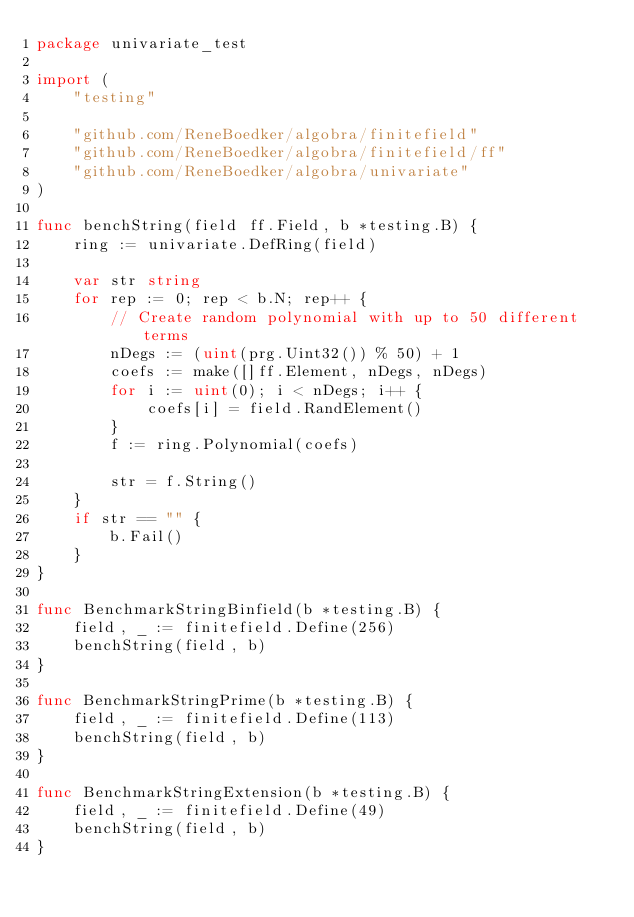Convert code to text. <code><loc_0><loc_0><loc_500><loc_500><_Go_>package univariate_test

import (
	"testing"

	"github.com/ReneBoedker/algobra/finitefield"
	"github.com/ReneBoedker/algobra/finitefield/ff"
	"github.com/ReneBoedker/algobra/univariate"
)

func benchString(field ff.Field, b *testing.B) {
	ring := univariate.DefRing(field)

	var str string
	for rep := 0; rep < b.N; rep++ {
		// Create random polynomial with up to 50 different terms
		nDegs := (uint(prg.Uint32()) % 50) + 1
		coefs := make([]ff.Element, nDegs, nDegs)
		for i := uint(0); i < nDegs; i++ {
			coefs[i] = field.RandElement()
		}
		f := ring.Polynomial(coefs)

		str = f.String()
	}
	if str == "" {
		b.Fail()
	}
}

func BenchmarkStringBinfield(b *testing.B) {
	field, _ := finitefield.Define(256)
	benchString(field, b)
}

func BenchmarkStringPrime(b *testing.B) {
	field, _ := finitefield.Define(113)
	benchString(field, b)
}

func BenchmarkStringExtension(b *testing.B) {
	field, _ := finitefield.Define(49)
	benchString(field, b)
}
</code> 